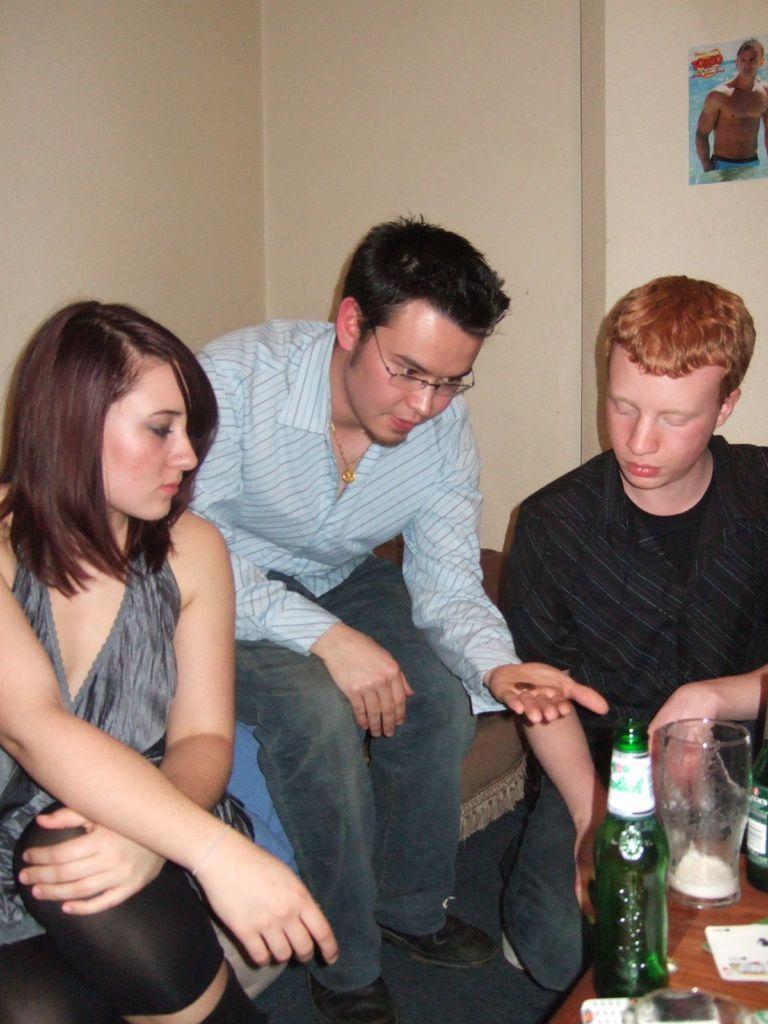Can you describe this image briefly? In this image I see a woman, and 2 men sitting and I see a table in front of them and there are 2 bottles, a glass and mobile. In the background I can see the wall and a poster. 